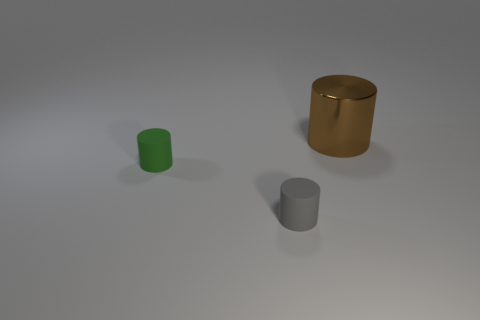Add 3 blue shiny things. How many objects exist? 6 Add 2 big things. How many big things are left? 3 Add 3 green matte things. How many green matte things exist? 4 Subtract 0 yellow balls. How many objects are left? 3 Subtract all purple blocks. Subtract all small gray rubber cylinders. How many objects are left? 2 